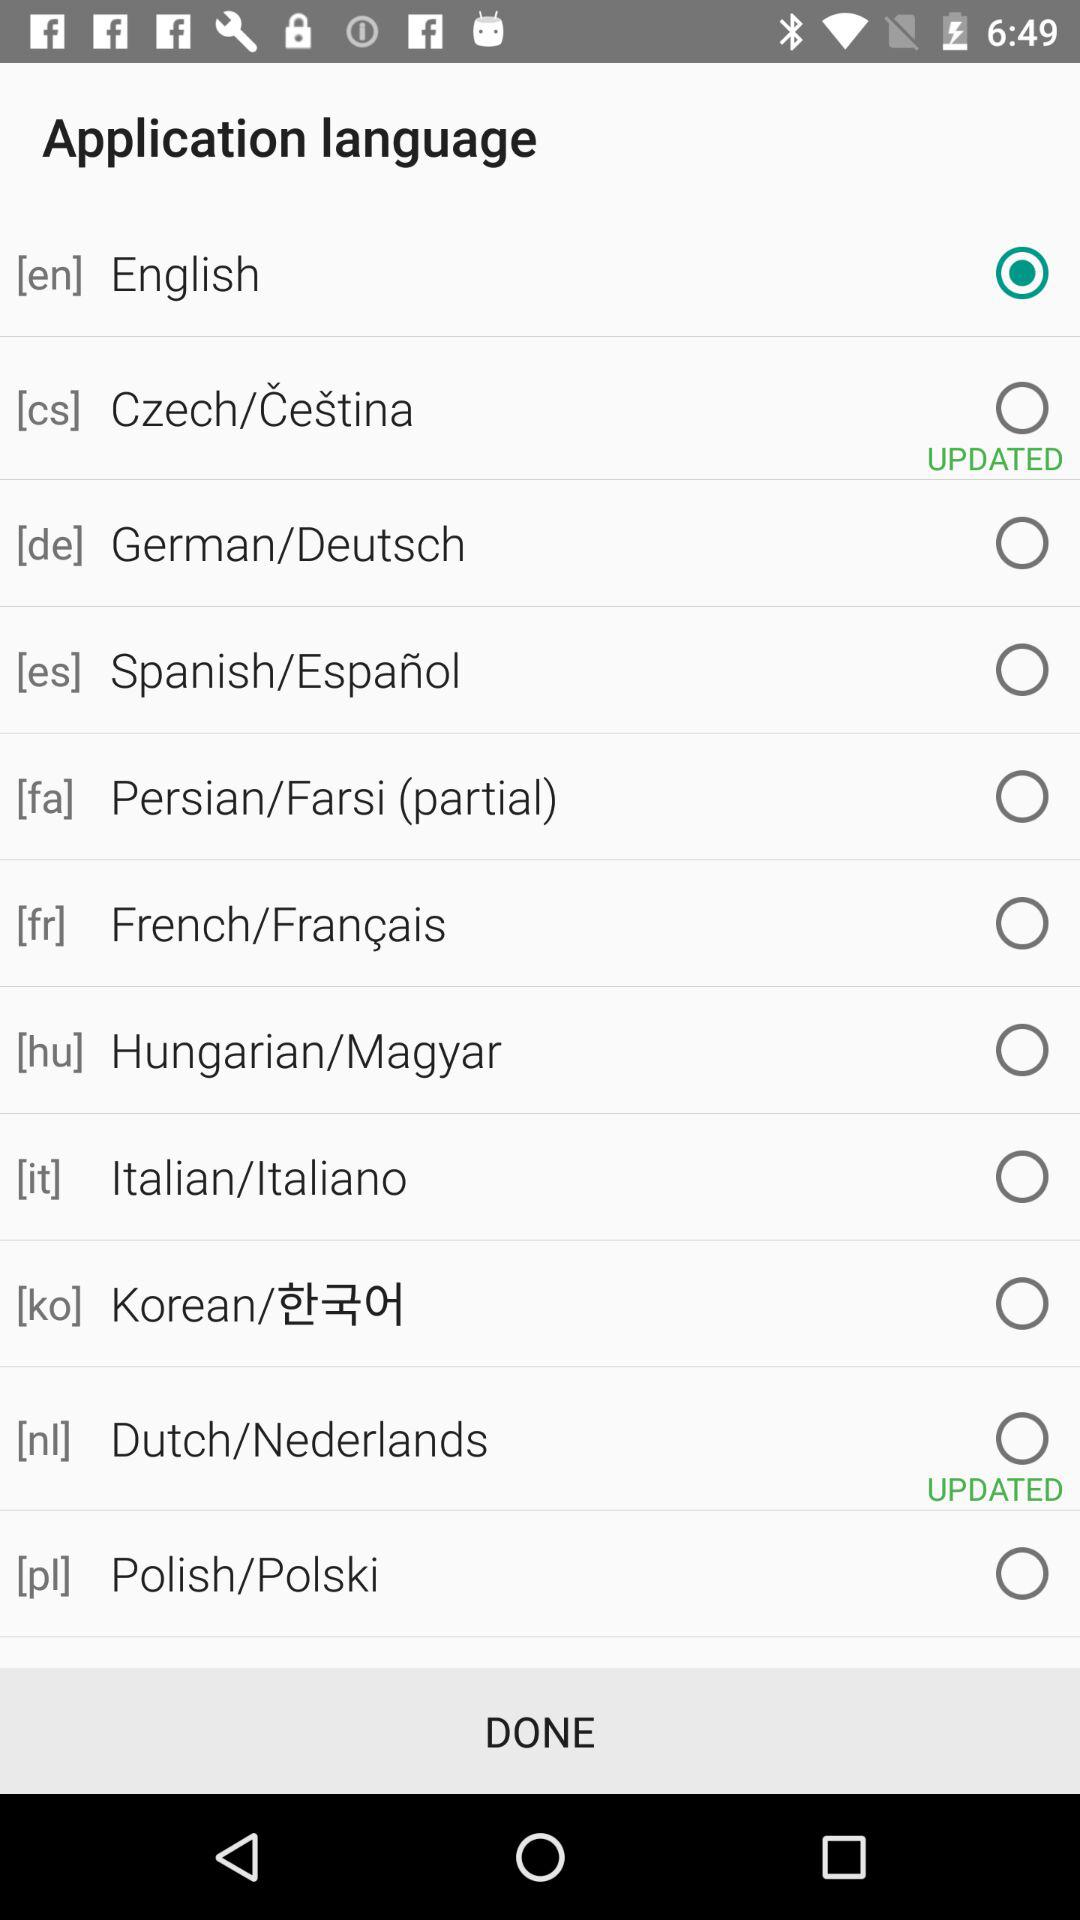What are the new languages updated? The updated new languages are Czech/Cestina and Dutch/Nederlands. 